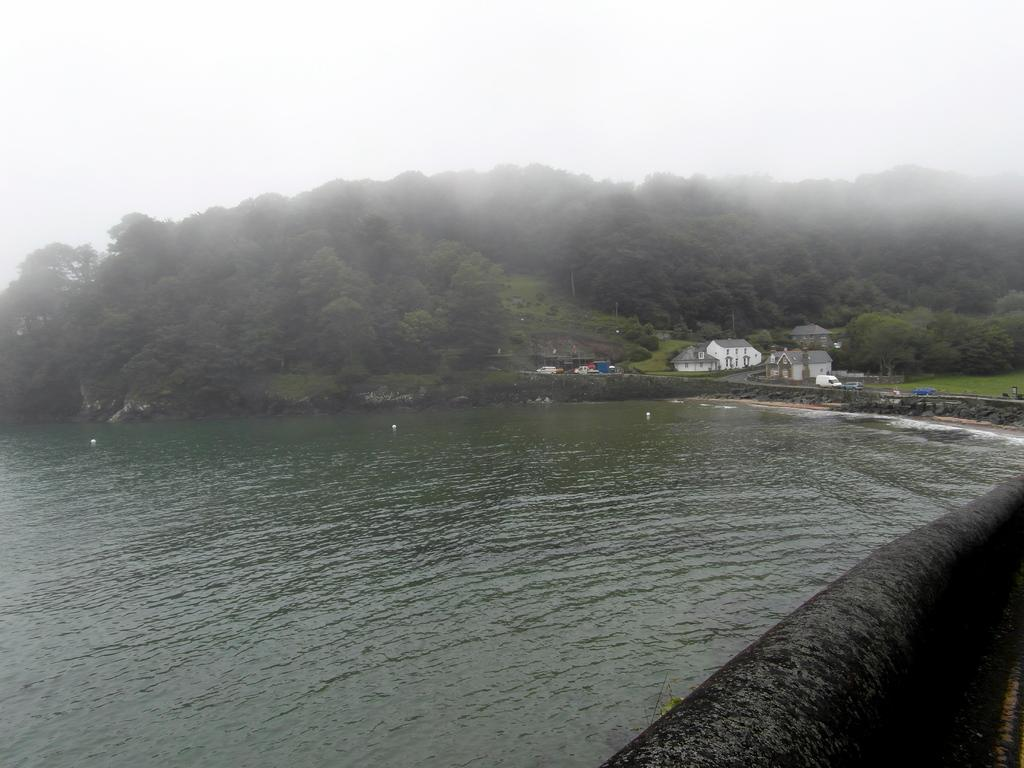What is the primary element in the image? There is a water surface in the image. What structures can be seen in the image? There are buildings visible in the image. What type of vegetation is present in the image? There are trees in the image. What can be seen in the sky in the image? Clouds are present in the sky in the image. Can you tell me how many toes are visible in the image? There are no toes visible in the image. Is anyone swimming in the water in the image? There is no indication of anyone swimming in the water in the image. 